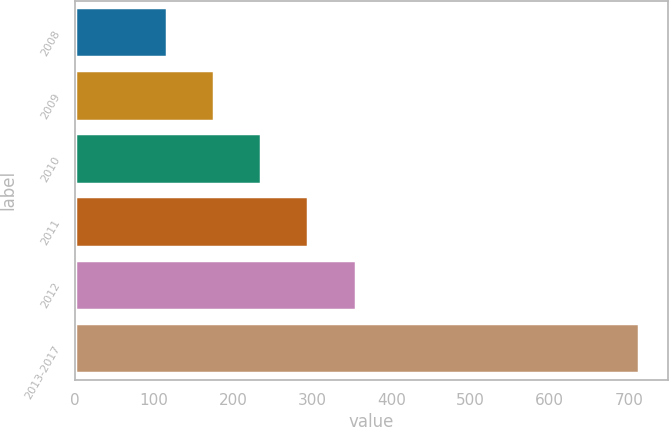<chart> <loc_0><loc_0><loc_500><loc_500><bar_chart><fcel>2008<fcel>2009<fcel>2010<fcel>2011<fcel>2012<fcel>2013-2017<nl><fcel>116<fcel>175.7<fcel>235.4<fcel>295.1<fcel>354.8<fcel>713<nl></chart> 